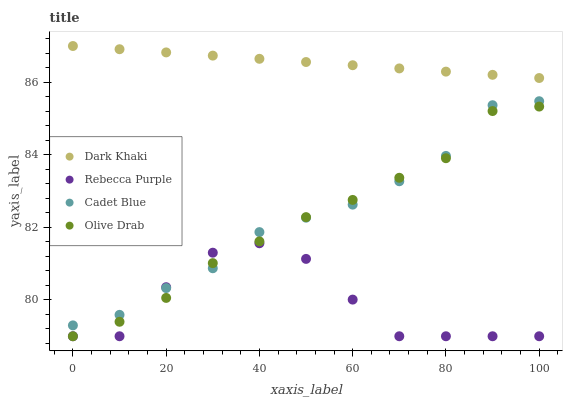Does Rebecca Purple have the minimum area under the curve?
Answer yes or no. Yes. Does Dark Khaki have the maximum area under the curve?
Answer yes or no. Yes. Does Cadet Blue have the minimum area under the curve?
Answer yes or no. No. Does Cadet Blue have the maximum area under the curve?
Answer yes or no. No. Is Dark Khaki the smoothest?
Answer yes or no. Yes. Is Rebecca Purple the roughest?
Answer yes or no. Yes. Is Cadet Blue the smoothest?
Answer yes or no. No. Is Cadet Blue the roughest?
Answer yes or no. No. Does Rebecca Purple have the lowest value?
Answer yes or no. Yes. Does Cadet Blue have the lowest value?
Answer yes or no. No. Does Dark Khaki have the highest value?
Answer yes or no. Yes. Does Cadet Blue have the highest value?
Answer yes or no. No. Is Rebecca Purple less than Dark Khaki?
Answer yes or no. Yes. Is Dark Khaki greater than Cadet Blue?
Answer yes or no. Yes. Does Olive Drab intersect Rebecca Purple?
Answer yes or no. Yes. Is Olive Drab less than Rebecca Purple?
Answer yes or no. No. Is Olive Drab greater than Rebecca Purple?
Answer yes or no. No. Does Rebecca Purple intersect Dark Khaki?
Answer yes or no. No. 